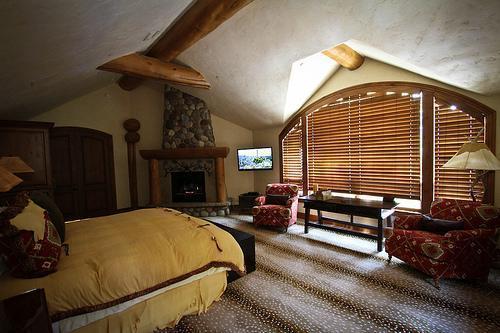How many chairs are there?
Give a very brief answer. 2. 